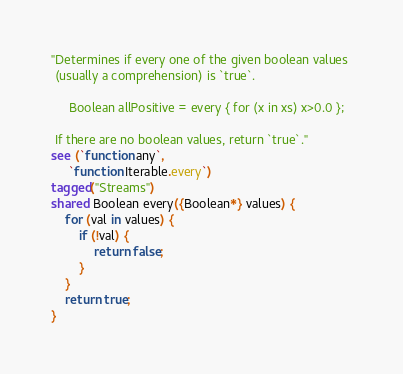<code> <loc_0><loc_0><loc_500><loc_500><_Ceylon_>"Determines if every one of the given boolean values 
 (usually a comprehension) is `true`.
 
     Boolean allPositive = every { for (x in xs) x>0.0 };
 
 If there are no boolean values, return `true`."
see (`function any`, 
     `function Iterable.every`)
tagged("Streams")
shared Boolean every({Boolean*} values) {
    for (val in values) {
        if (!val) {
            return false;
        }
    }
    return true;
}
</code> 